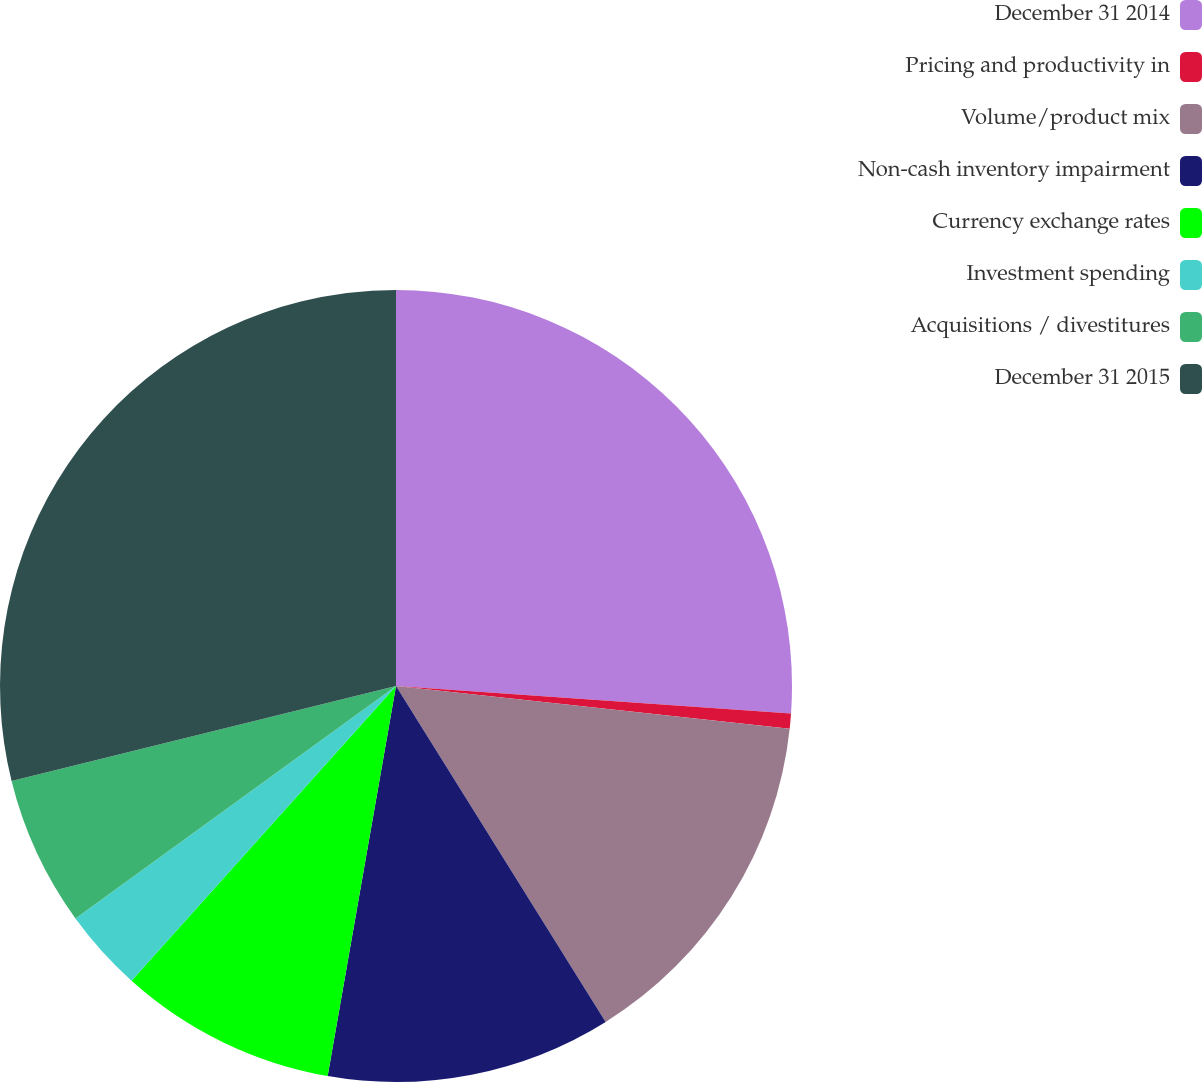Convert chart to OTSL. <chart><loc_0><loc_0><loc_500><loc_500><pie_chart><fcel>December 31 2014<fcel>Pricing and productivity in<fcel>Volume/product mix<fcel>Non-cash inventory impairment<fcel>Currency exchange rates<fcel>Investment spending<fcel>Acquisitions / divestitures<fcel>December 31 2015<nl><fcel>26.11%<fcel>0.61%<fcel>14.4%<fcel>11.64%<fcel>8.88%<fcel>3.37%<fcel>6.13%<fcel>28.86%<nl></chart> 